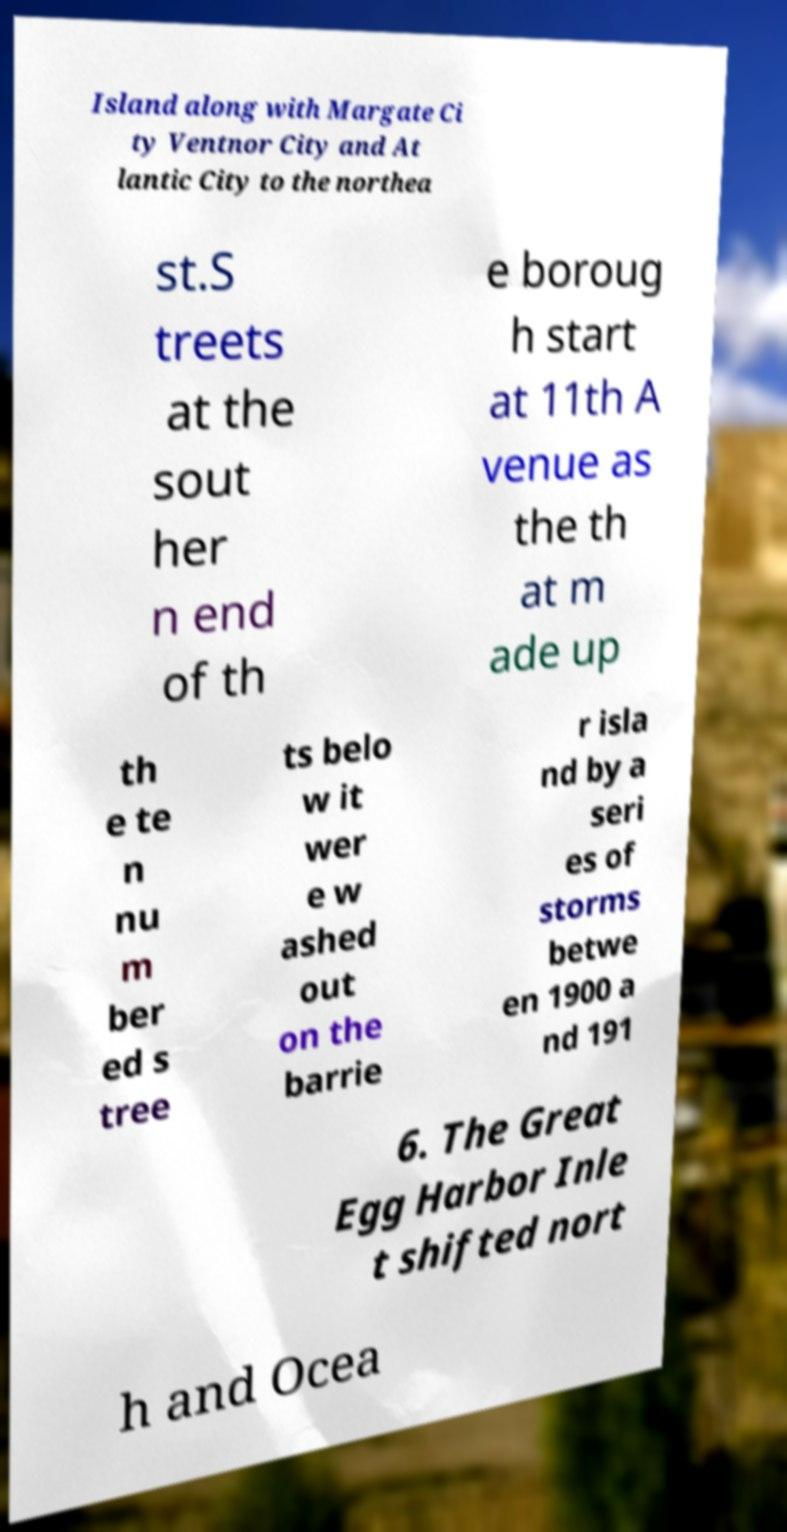I need the written content from this picture converted into text. Can you do that? Island along with Margate Ci ty Ventnor City and At lantic City to the northea st.S treets at the sout her n end of th e boroug h start at 11th A venue as the th at m ade up th e te n nu m ber ed s tree ts belo w it wer e w ashed out on the barrie r isla nd by a seri es of storms betwe en 1900 a nd 191 6. The Great Egg Harbor Inle t shifted nort h and Ocea 